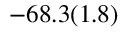Convert formula to latex. <formula><loc_0><loc_0><loc_500><loc_500>- 6 8 . 3 ( 1 . 8 )</formula> 